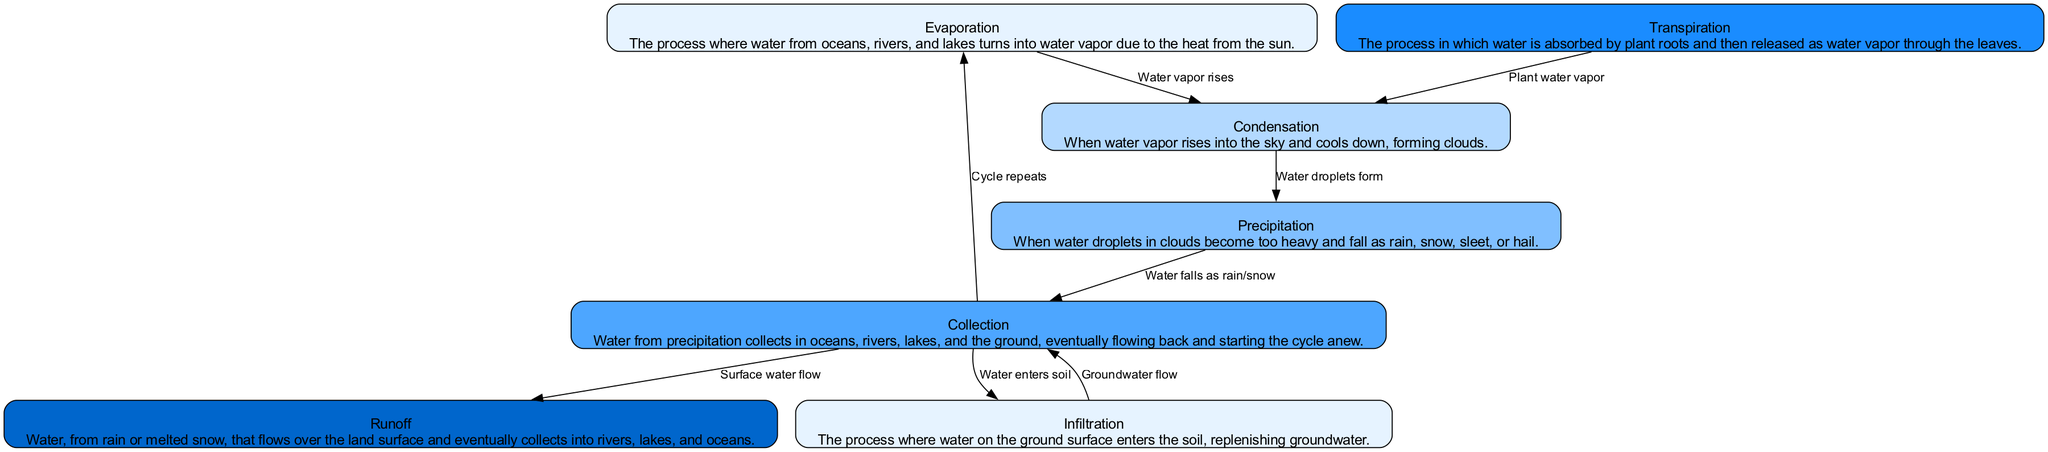What is the first stage of the water cycle? The diagram starts with "Evaporation" as the first node, indicating that it is the first stage in the water cycle.
Answer: Evaporation How many main stages are there in the water cycle as illustrated by the diagram? The diagram lists seven distinct stages: Evaporation, Condensation, Precipitation, Collection, Transpiration, Runoff, and Infiltration. By counting these, we can determine the total number of main stages.
Answer: Seven What process occurs between Condensation and Precipitation? The diagram shows an edge labeled "Water droplets form" that connects "Condensation" to "Precipitation," indicating that this is the process that takes place between these two stages.
Answer: Water droplets form What happens to the water during the Collection stage? The arrow from "Precipitation" leads to "Collection," with the label indicating that "Water falls as rain/snow," and during Collection, waters from rain or melted snow are accumulated in lakes, rivers, and oceans.
Answer: Water falls as rain/snow How does Transpiration relate to Condensation in the diagram? The edge from "Transpiration" to "Condensation" is labeled "Plant water vapor," indicating that water vapor released from plants contributes to the process of forming clouds in condensation.
Answer: Plant water vapor What is the role of Infiltration in the water cycle? The edge from "Collection" to "Infiltration" describes how water enters the soil, which replenishes groundwater. This indicates that Infiltration is involved in returning water back underground.
Answer: Water enters soil How does Runoff occur and where does it flow after? The diagram shows an edge from "Collection" to "Runoff" labeled "Surface water flow," meaning that runoff occurs when water flows over the land surface towards rivers, lakes, and oceans.
Answer: Surface water flow What is the significance of the arrows in the diagram? The arrows in the diagram indicate the direction of the water movement and the relationships between the different stages in the water cycle, clarifying how each step connects and leads to the next one in the cycle.
Answer: Direction of water movement 